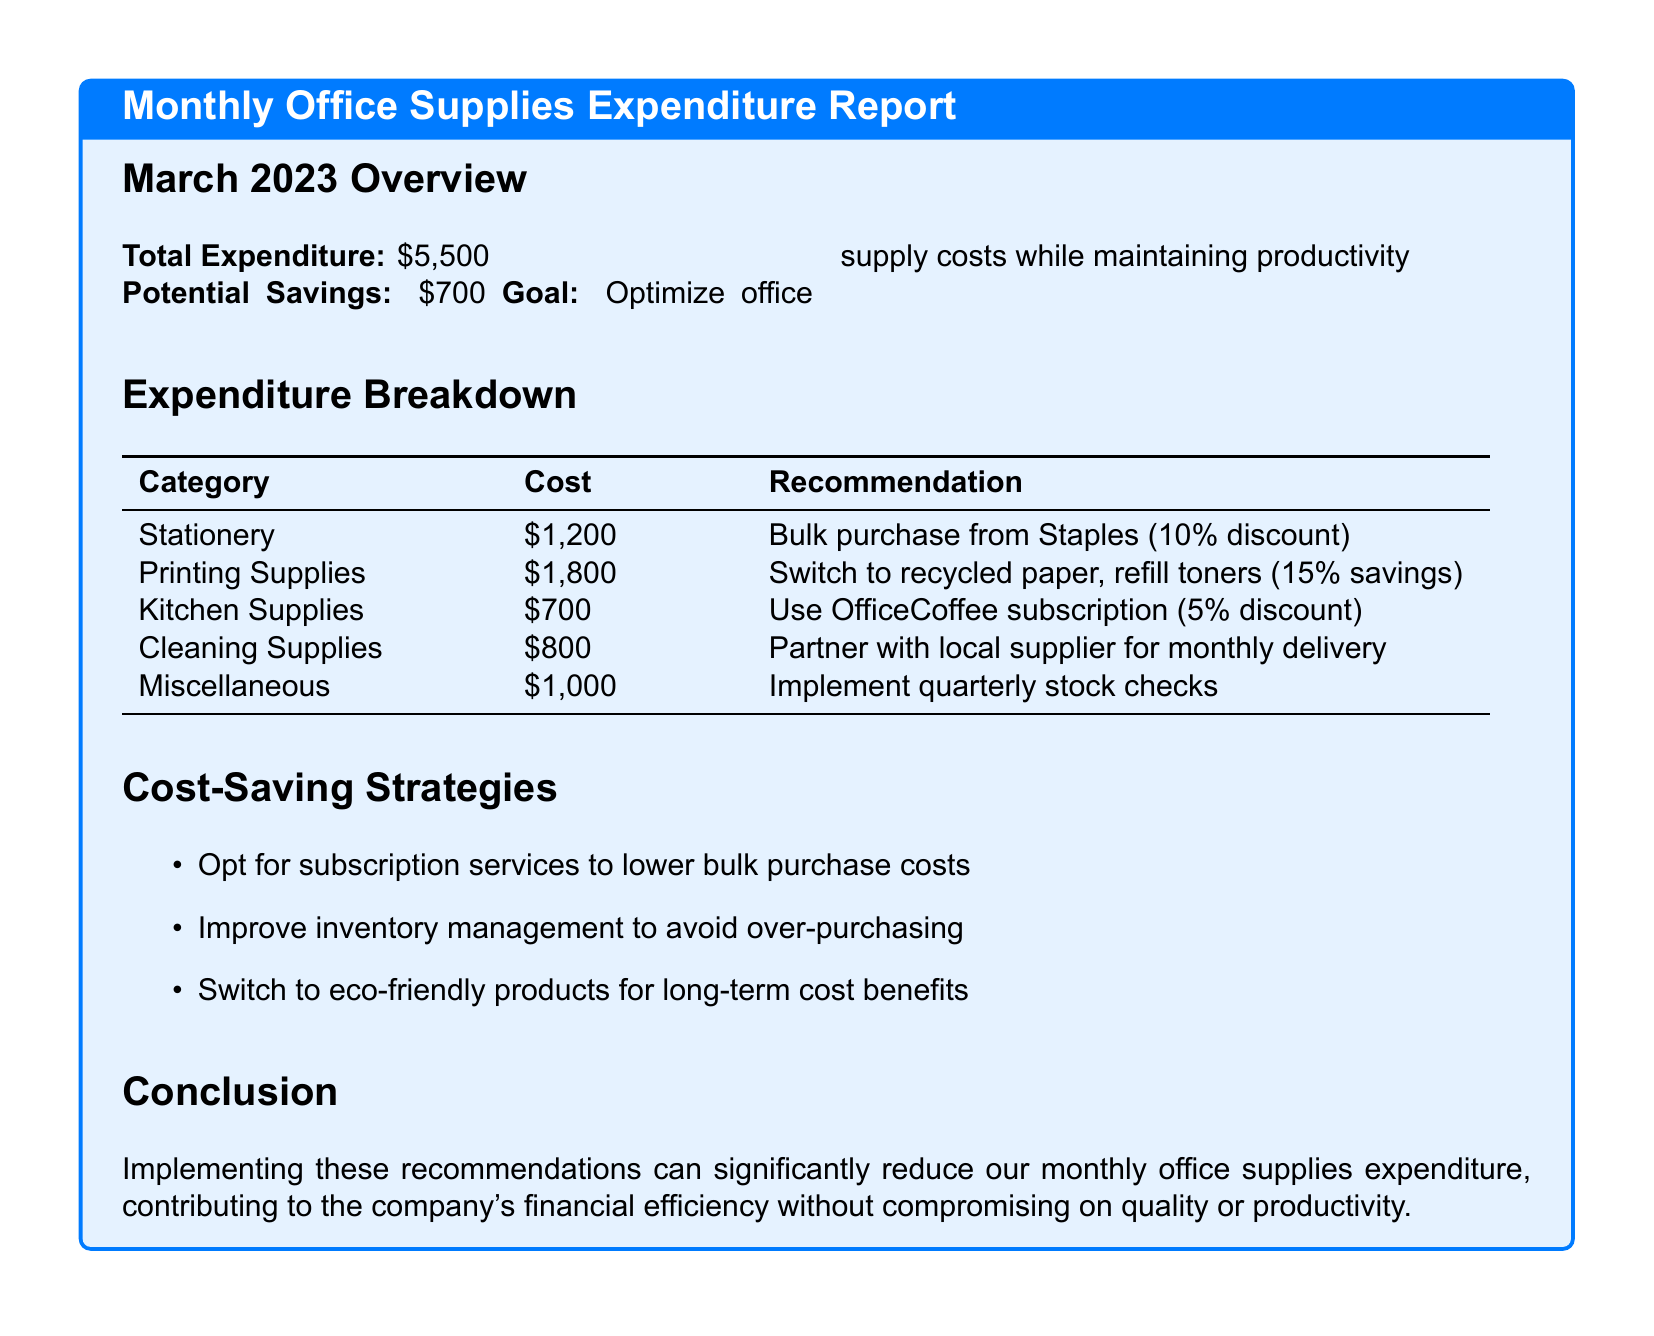what is the total expenditure for March 2023? The total expenditure is explicitly mentioned in the overview section of the report.
Answer: $5,500 what are the potential savings identified in the report? The potential savings are listed under the overview section as well.
Answer: $700 which category has the highest expenditure? The highest expenditure category can be identified from the expenditure breakdown table.
Answer: Printing Supplies what is the recommended action for stationery purchases? The recommendation is directly stated in the expenditure breakdown table.
Answer: Bulk purchase from Staples (10% discount) what is the suggested saving method for kitchen supplies? This information is provided in the expenditure breakdown table as well.
Answer: Use OfficeCoffee subscription (5% discount) how much is recommended to be saved by switching to recycled paper? The savings from switching to recycled paper are indicated in the expenditures section.
Answer: 15% savings what is one of the cost-saving strategies proposed in the report? Strategies are listed in the cost-saving strategies section.
Answer: Improve inventory management how many categories are listed in the expenditure breakdown? The expenditure breakdown table lists several categories, which can be counted.
Answer: 5 what is the overall goal of optimizing office supply costs? The goal is mentioned in the overview section of the report.
Answer: Maintain productivity 